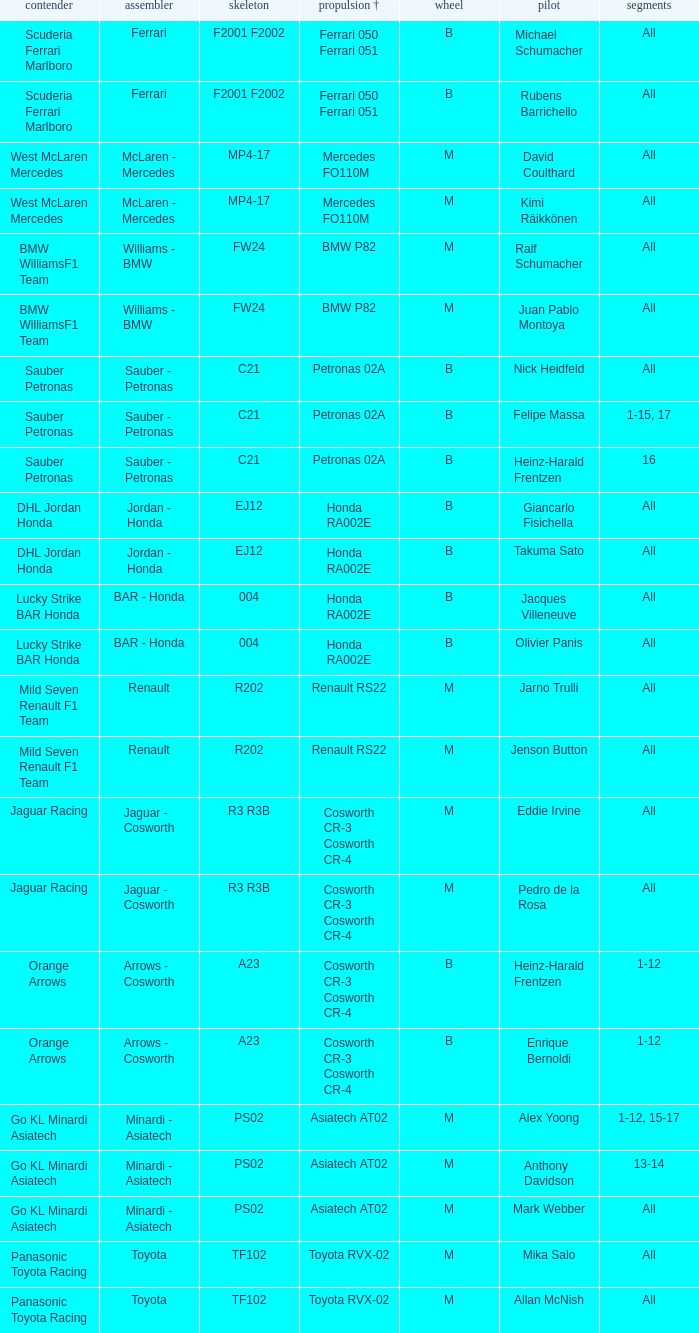What is the tyre when the engine is asiatech at02 and the driver is alex yoong? M. 